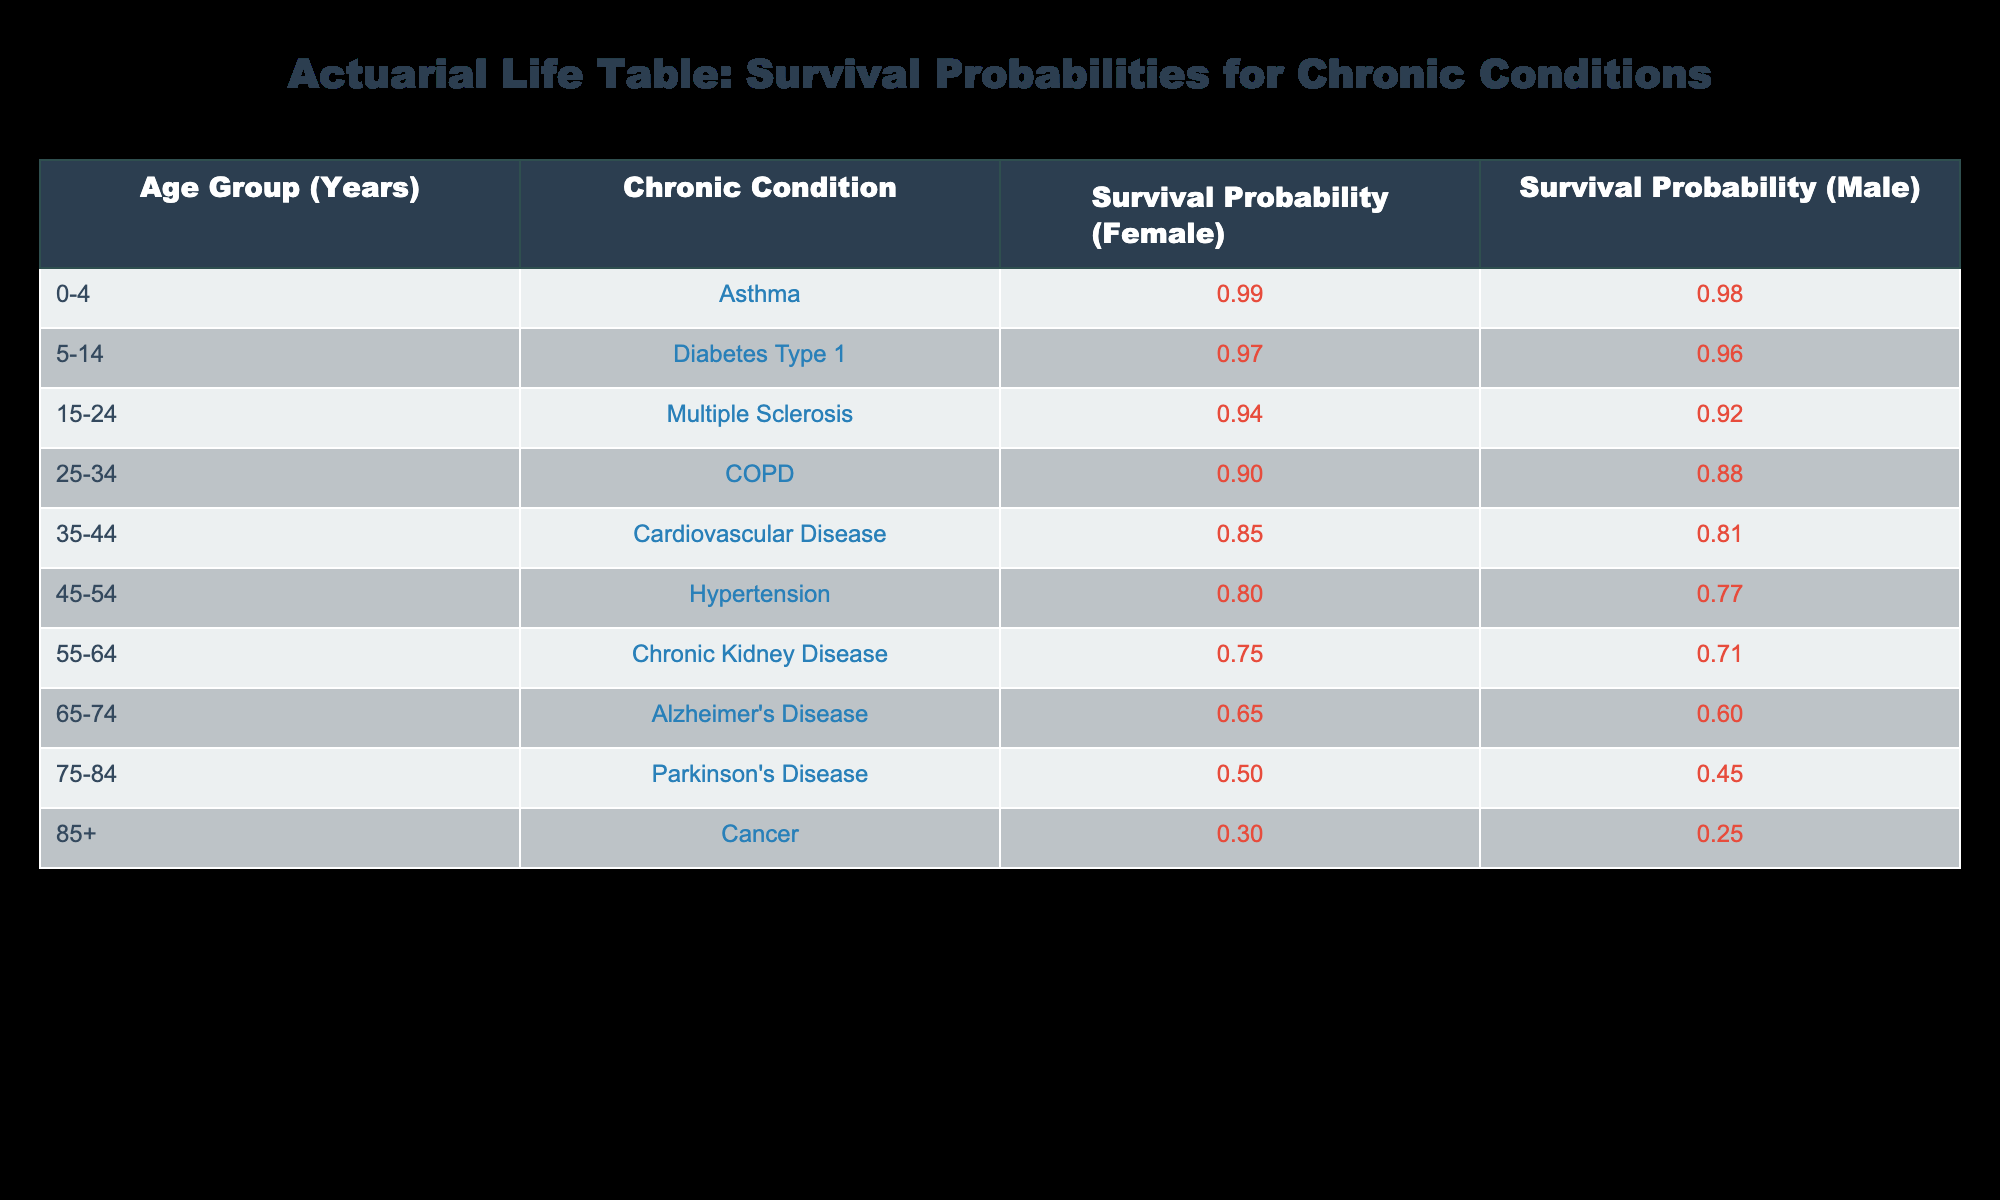What is the survival probability for males aged 55-64 with chronic kidney disease? According to the table, the survival probability for males aged 55-64 with chronic kidney disease is listed directly under the "Survival Probability (Male)" column for that age group. The value provided is 0.71.
Answer: 0.71 What is the survival probability for females aged 75-84 with Parkinson’s Disease? The table shows the survival probability for females aged 75-84 with Parkinson’s Disease. The probability is found in the "Survival Probability (Female)" column for that specific age group, which is 0.50.
Answer: 0.50 Which chronic condition has the highest survival probability for females in the age group 0-4? The age group 0-4 has asthma listed, and the corresponding survival probability for females is 0.99. This is the highest probability among other chronic conditions for that age group.
Answer: 0.99 Is it true that the survival probability for males with cardiovascular disease is greater than that for females with the same condition? From the table, the survival probability for males with cardiovascular disease is 0.81, while for females it is 0.85. Since 0.81 is not greater than 0.85, the statement is false.
Answer: No What is the average survival probability for both males and females in the age group 25-34? The survival probability for females in the age group 25-34 is 0.90, and for males, it is 0.88. To find the average, add both probabilities: 0.90 + 0.88 = 1.78. Then divide by 2 to get the average: 1.78 / 2 = 0.89.
Answer: 0.89 Which age group shows the largest difference in survival probabilities between males and females? To determine the largest difference, compare the "Survival Probability (Female)" and "Survival Probability (Male)" for each age group. The biggest difference is seen in the 85+ age group, where the survival probability is 0.30 for females and 0.25 for males, resulting in a difference of 0.05.
Answer: 85+ age group What is the survival probability for individuals aged 65-74 with Alzheimer’s disease? The survival probability for both males and females aged 65-74 with Alzheimer’s disease is displayed in the table, where the value is 0.65 for females and 0.60 for males.
Answer: 0.65 (female), 0.60 (male) Are survival probabilities higher for females than males across all chronic conditions in the table? Evaluating the survival probabilities across all available chronic conditions, females generally have higher probabilities. However, for certain chronic conditions and age groups, males may have equal or lower survival probabilities, thus the statement is false.
Answer: No 